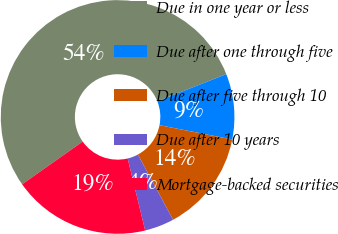Convert chart. <chart><loc_0><loc_0><loc_500><loc_500><pie_chart><fcel>Due in one year or less<fcel>Due after one through five<fcel>Due after five through 10<fcel>Due after 10 years<fcel>Mortgage-backed securities<nl><fcel>53.8%<fcel>9.06%<fcel>14.03%<fcel>4.09%<fcel>19.01%<nl></chart> 